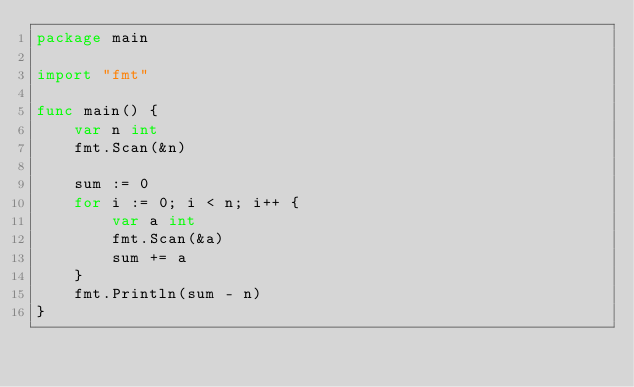<code> <loc_0><loc_0><loc_500><loc_500><_Go_>package main

import "fmt"

func main() {
	var n int
	fmt.Scan(&n)

	sum := 0
	for i := 0; i < n; i++ {
		var a int
		fmt.Scan(&a)
		sum += a
	}
	fmt.Println(sum - n)
}</code> 